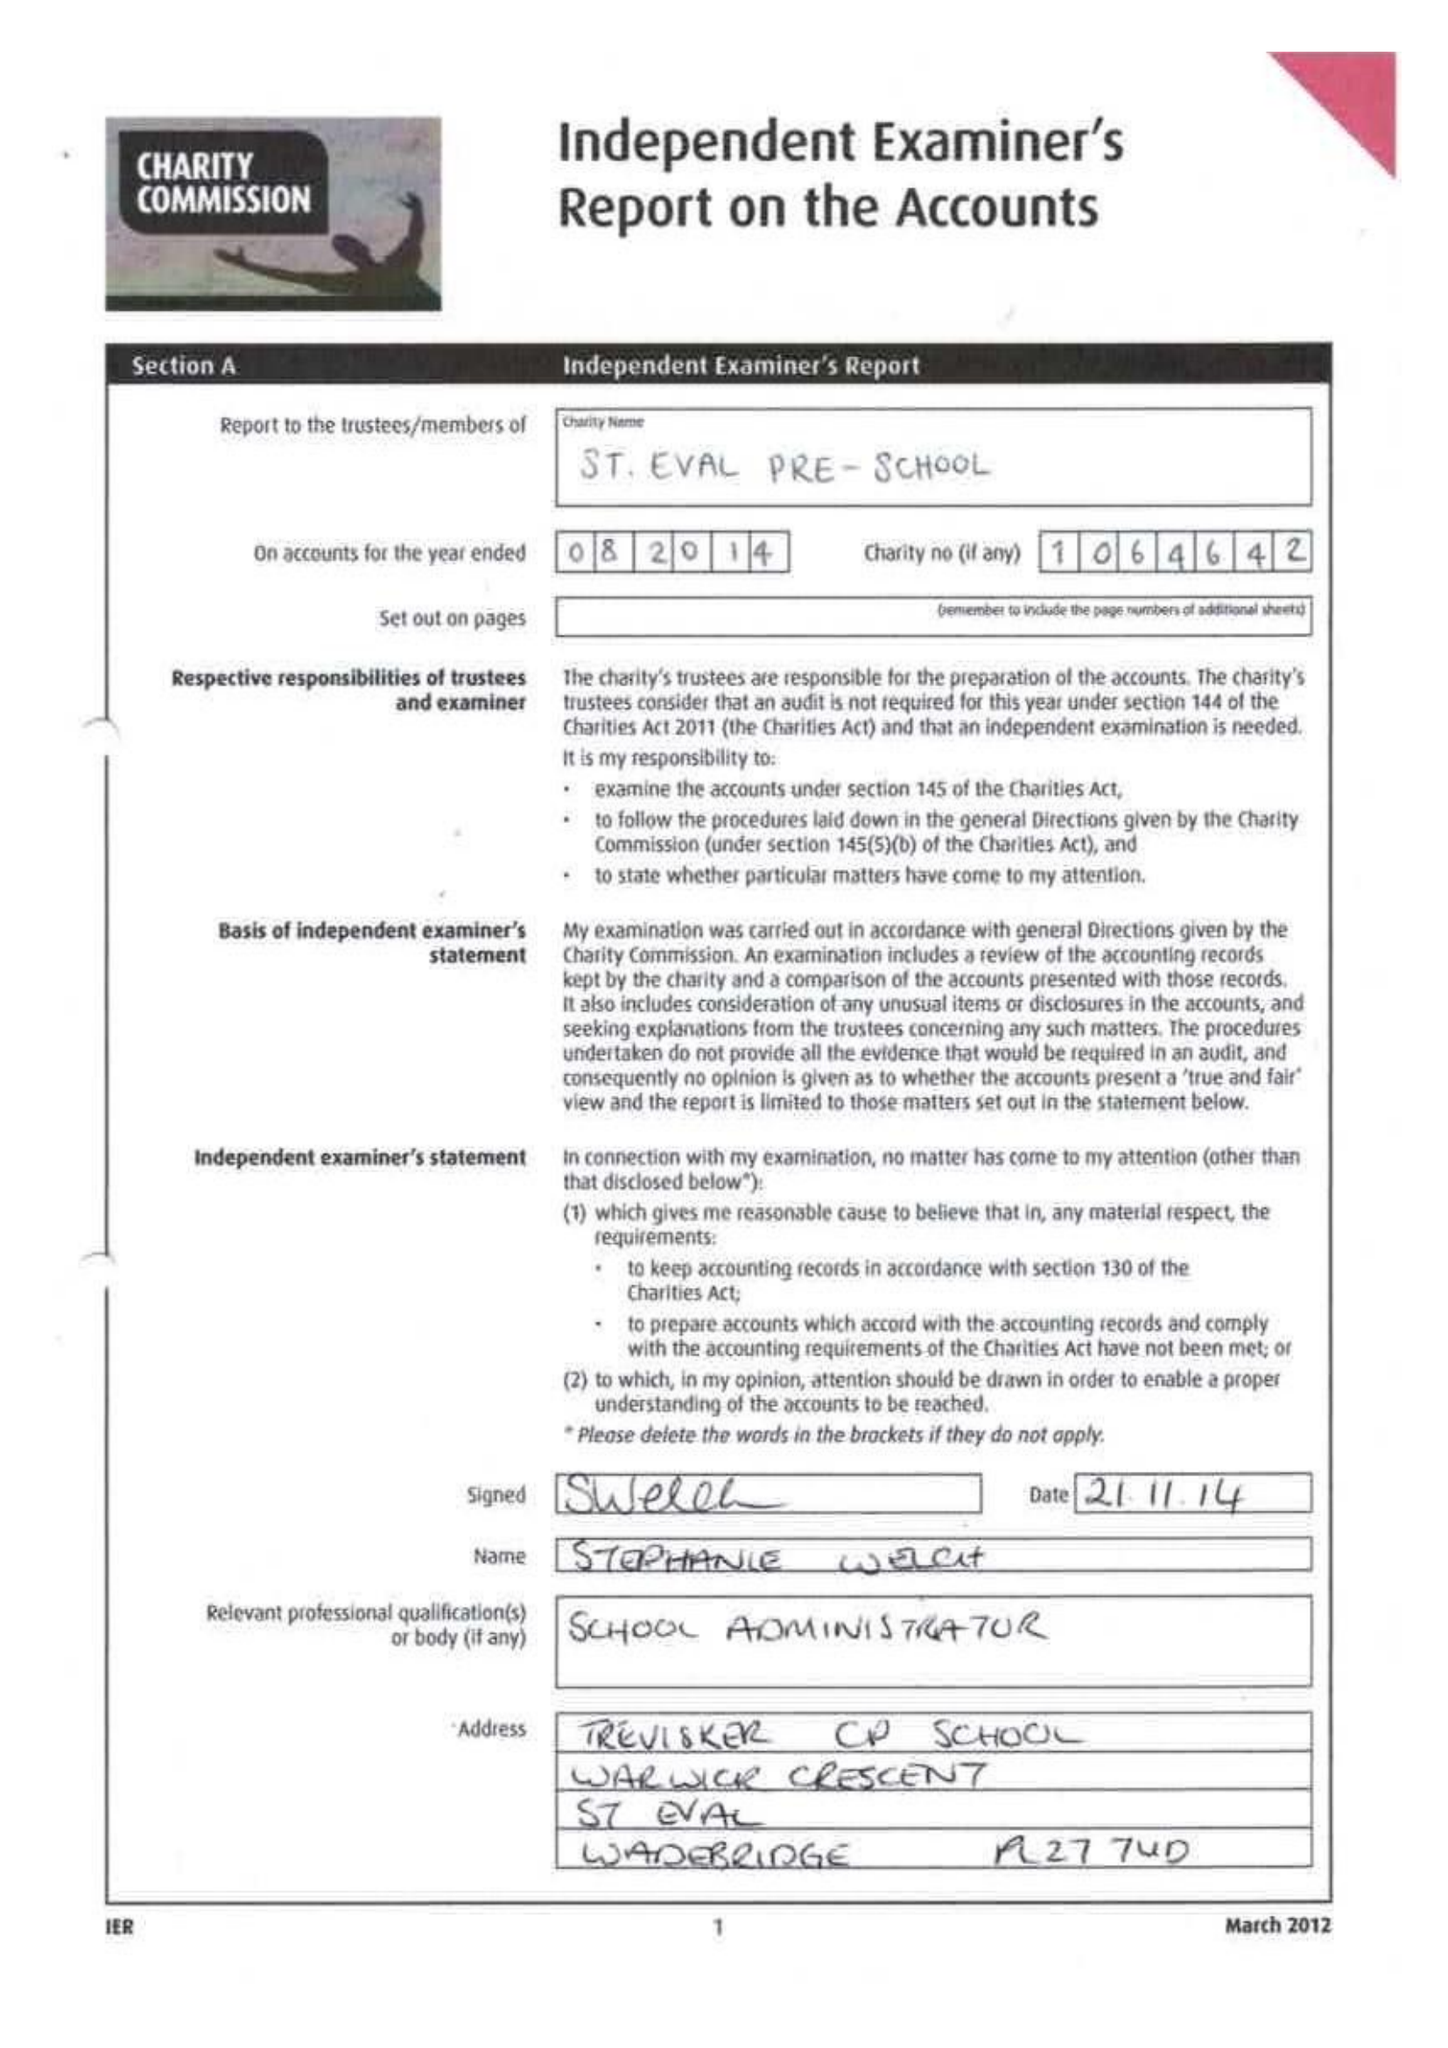What is the value for the charity_name?
Answer the question using a single word or phrase. St Eval Pre-School Playgroup 